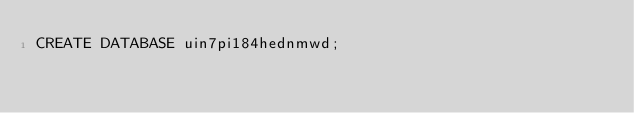<code> <loc_0><loc_0><loc_500><loc_500><_SQL_>CREATE DATABASE uin7pi184hednmwd;</code> 